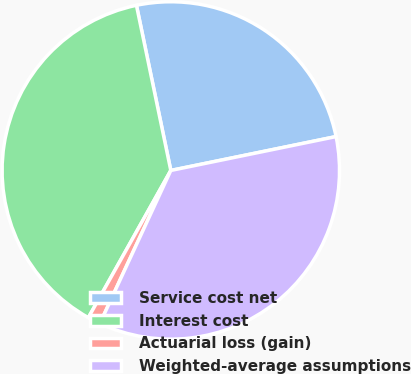<chart> <loc_0><loc_0><loc_500><loc_500><pie_chart><fcel>Service cost net<fcel>Interest cost<fcel>Actuarial loss (gain)<fcel>Weighted-average assumptions<nl><fcel>25.05%<fcel>38.61%<fcel>1.22%<fcel>35.13%<nl></chart> 